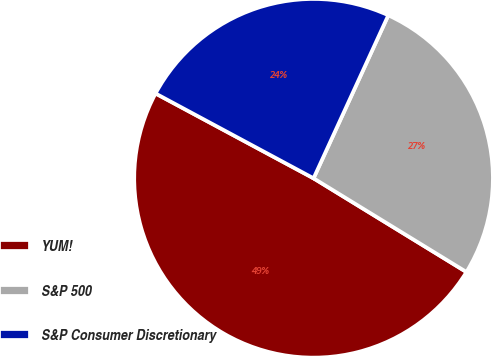Convert chart to OTSL. <chart><loc_0><loc_0><loc_500><loc_500><pie_chart><fcel>YUM!<fcel>S&P 500<fcel>S&P Consumer Discretionary<nl><fcel>49.09%<fcel>26.91%<fcel>24.0%<nl></chart> 